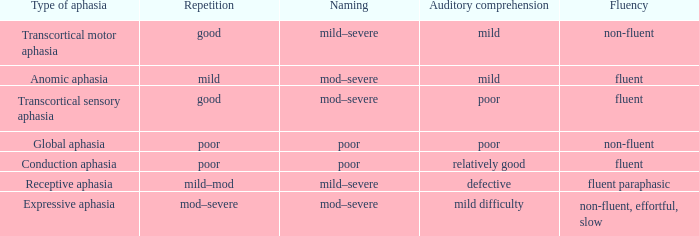Would you mind parsing the complete table? {'header': ['Type of aphasia', 'Repetition', 'Naming', 'Auditory comprehension', 'Fluency'], 'rows': [['Transcortical motor aphasia', 'good', 'mild–severe', 'mild', 'non-fluent'], ['Anomic aphasia', 'mild', 'mod–severe', 'mild', 'fluent'], ['Transcortical sensory aphasia', 'good', 'mod–severe', 'poor', 'fluent'], ['Global aphasia', 'poor', 'poor', 'poor', 'non-fluent'], ['Conduction aphasia', 'poor', 'poor', 'relatively good', 'fluent'], ['Receptive aphasia', 'mild–mod', 'mild–severe', 'defective', 'fluent paraphasic'], ['Expressive aphasia', 'mod–severe', 'mod–severe', 'mild difficulty', 'non-fluent, effortful, slow']]} Name the number of naming for anomic aphasia 1.0. 